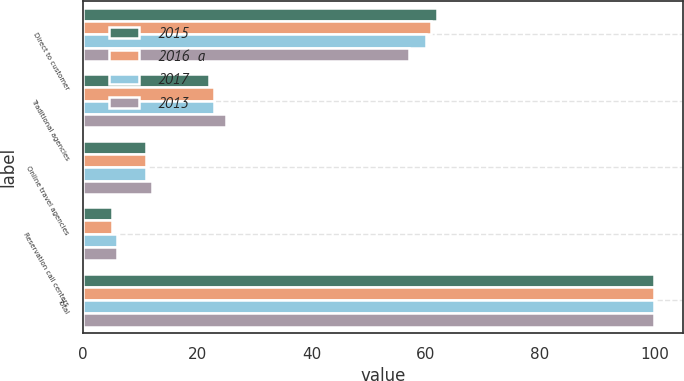<chart> <loc_0><loc_0><loc_500><loc_500><stacked_bar_chart><ecel><fcel>Direct to customer<fcel>Traditional agencies<fcel>Online travel agencies<fcel>Reservation call centers<fcel>Total<nl><fcel>2015<fcel>62<fcel>22<fcel>11<fcel>5<fcel>100<nl><fcel>2016  a<fcel>61<fcel>23<fcel>11<fcel>5<fcel>100<nl><fcel>2017<fcel>60<fcel>23<fcel>11<fcel>6<fcel>100<nl><fcel>2013<fcel>57<fcel>25<fcel>12<fcel>6<fcel>100<nl></chart> 